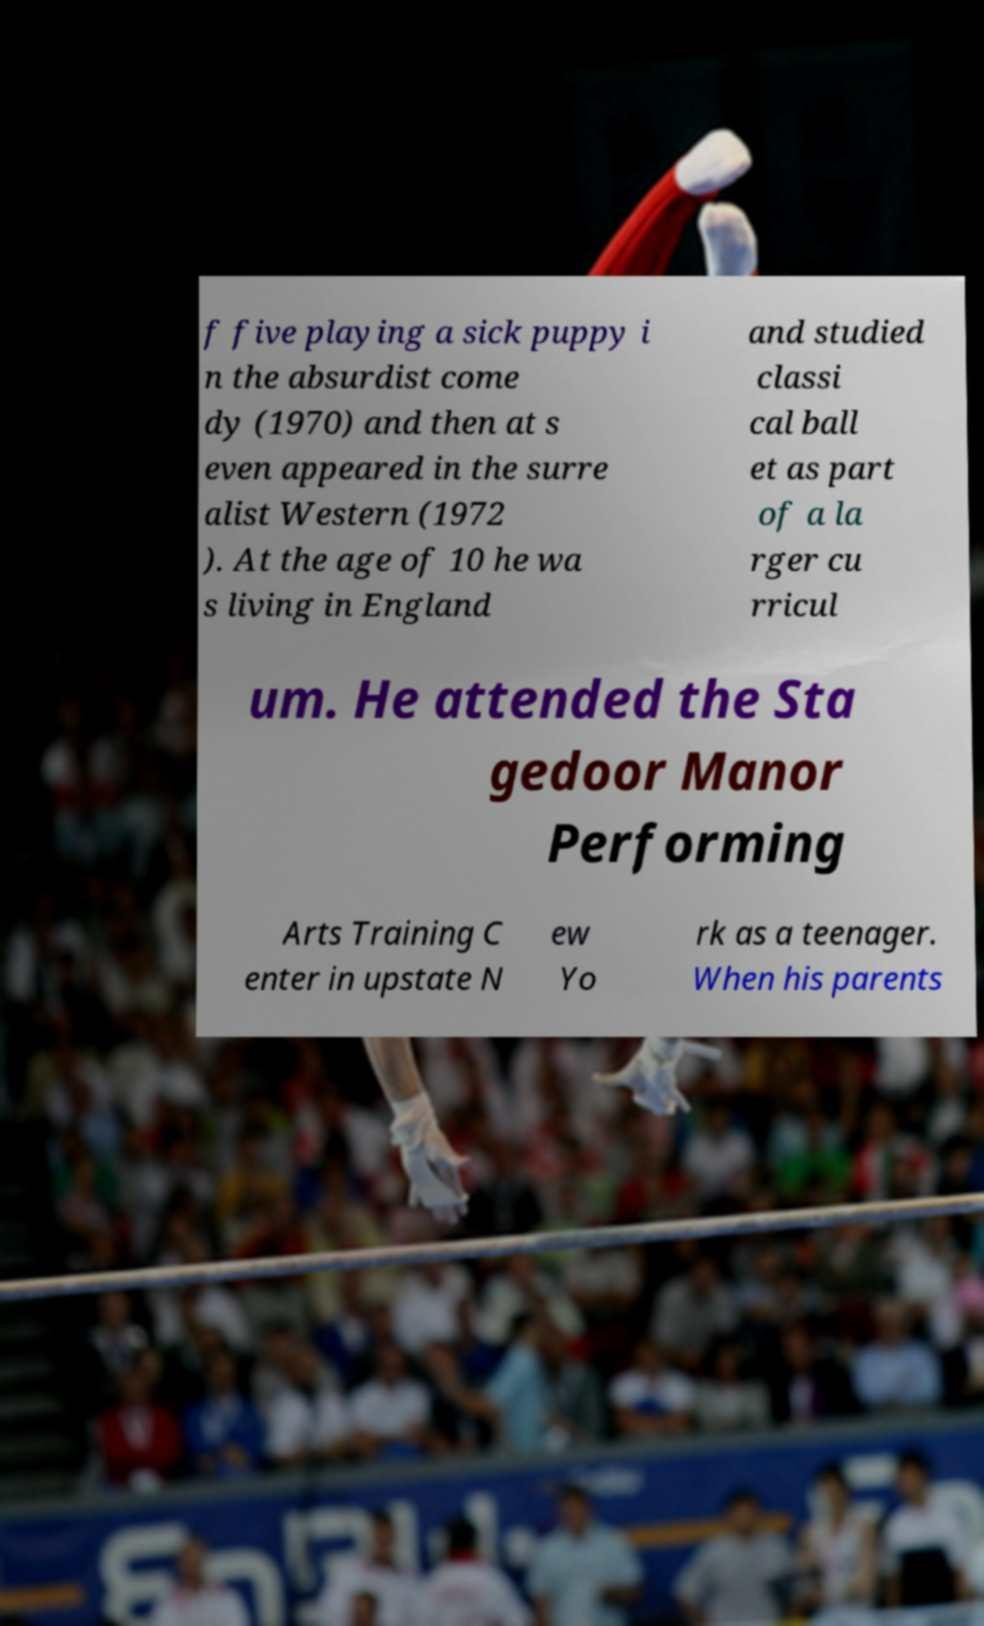Can you read and provide the text displayed in the image?This photo seems to have some interesting text. Can you extract and type it out for me? f five playing a sick puppy i n the absurdist come dy (1970) and then at s even appeared in the surre alist Western (1972 ). At the age of 10 he wa s living in England and studied classi cal ball et as part of a la rger cu rricul um. He attended the Sta gedoor Manor Performing Arts Training C enter in upstate N ew Yo rk as a teenager. When his parents 